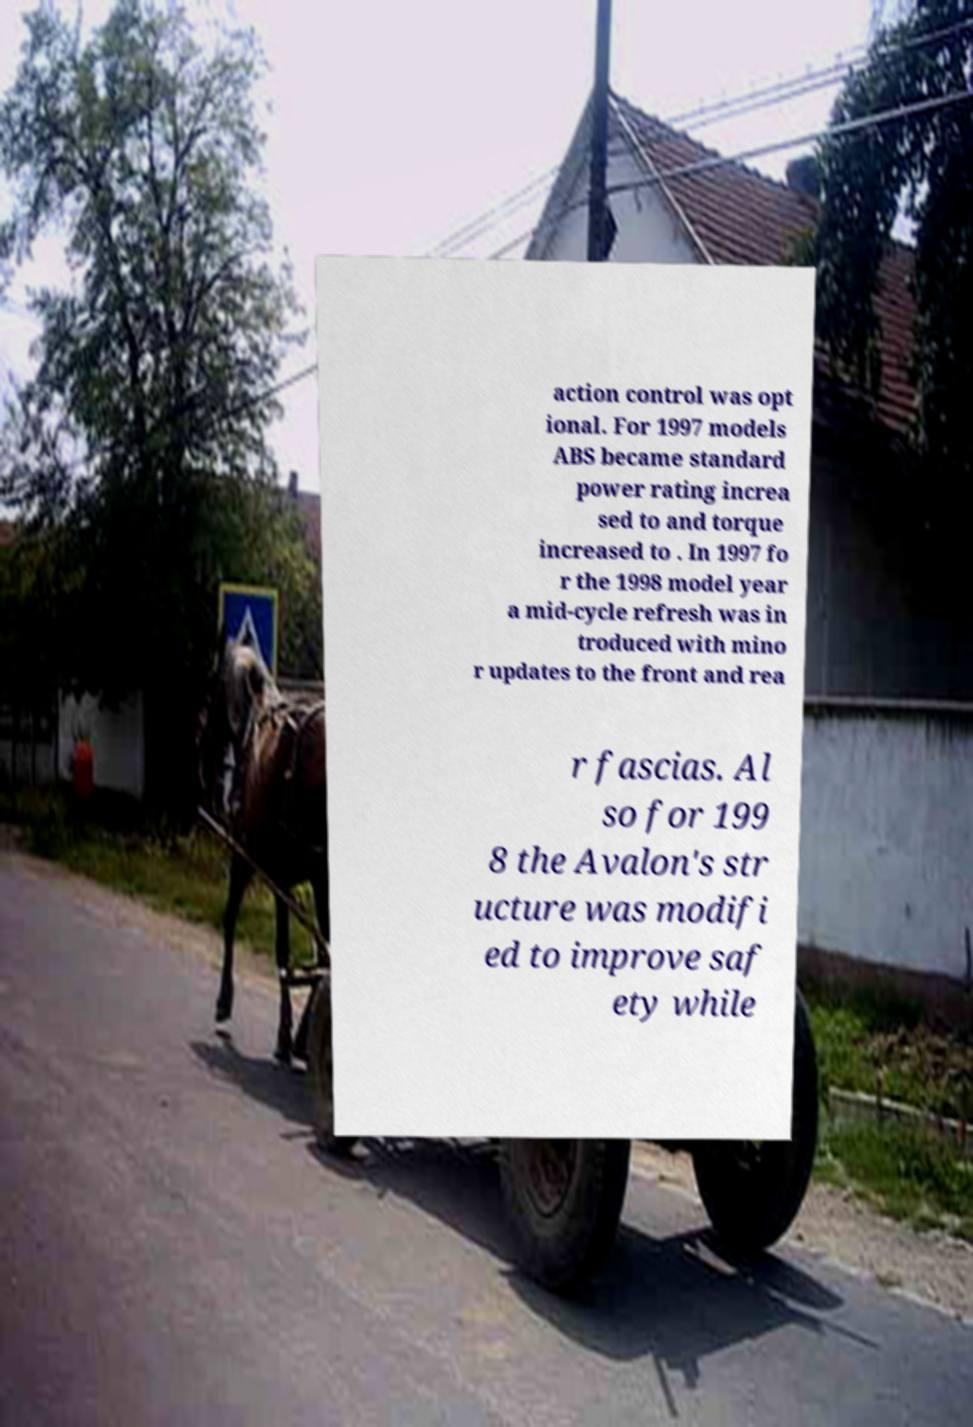For documentation purposes, I need the text within this image transcribed. Could you provide that? action control was opt ional. For 1997 models ABS became standard power rating increa sed to and torque increased to . In 1997 fo r the 1998 model year a mid-cycle refresh was in troduced with mino r updates to the front and rea r fascias. Al so for 199 8 the Avalon's str ucture was modifi ed to improve saf ety while 